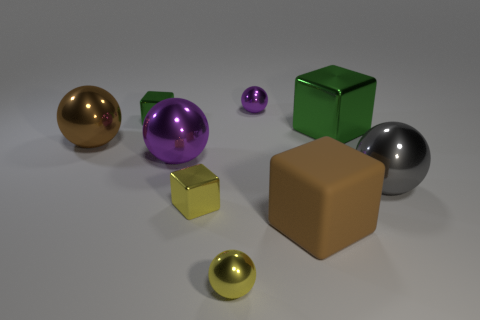How many metal spheres are both in front of the small purple metal thing and right of the small green thing?
Give a very brief answer. 3. Are there an equal number of spheres that are on the left side of the small green thing and brown matte objects that are to the left of the big brown metallic sphere?
Ensure brevity in your answer.  No. There is a purple shiny thing that is left of the yellow ball; is its shape the same as the gray shiny thing?
Offer a very short reply. Yes. There is a tiny shiny thing to the left of the tiny cube in front of the ball to the right of the large brown rubber thing; what is its shape?
Provide a short and direct response. Cube. What is the shape of the big metallic thing that is the same color as the rubber thing?
Make the answer very short. Sphere. What is the block that is on the right side of the tiny purple ball and behind the large matte object made of?
Your response must be concise. Metal. Is the number of large cyan shiny blocks less than the number of brown cubes?
Your answer should be very brief. Yes. Is the shape of the large matte object the same as the large brown thing behind the gray thing?
Make the answer very short. No. Is the size of the purple object behind the brown metal thing the same as the large green thing?
Keep it short and to the point. No. What shape is the green object that is the same size as the brown block?
Provide a succinct answer. Cube. 